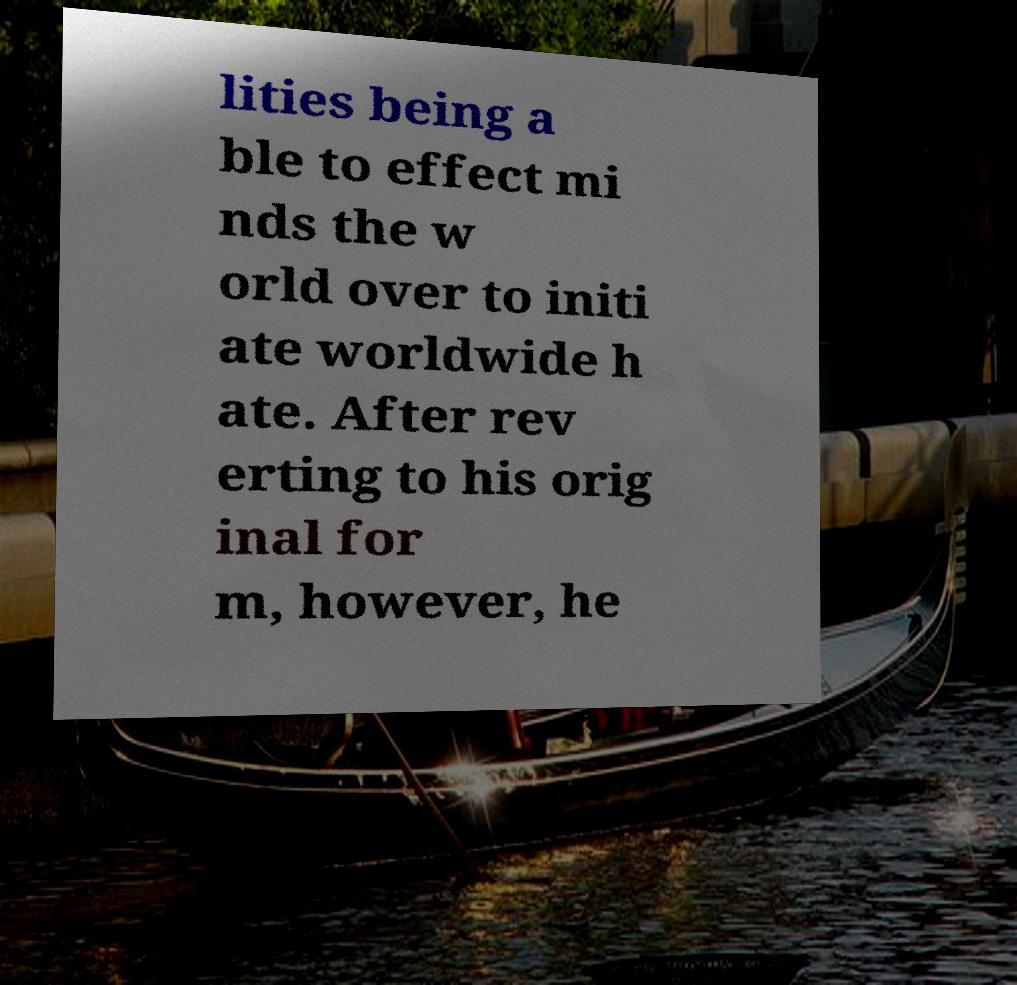I need the written content from this picture converted into text. Can you do that? lities being a ble to effect mi nds the w orld over to initi ate worldwide h ate. After rev erting to his orig inal for m, however, he 